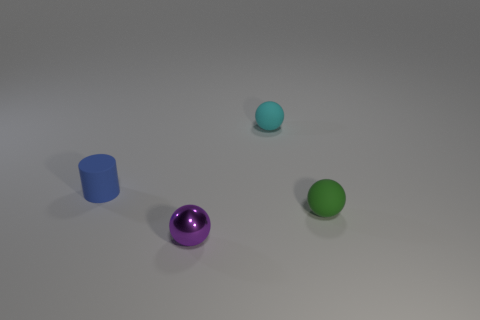Are there fewer purple objects behind the small cyan matte ball than small cyan rubber things?
Your answer should be compact. Yes. Are there any small purple things of the same shape as the blue object?
Make the answer very short. No. What shape is the green object that is the same size as the metal ball?
Offer a very short reply. Sphere. What number of things are tiny purple spheres or big gray matte things?
Ensure brevity in your answer.  1. Are there any big gray shiny things?
Provide a short and direct response. No. Are there fewer big brown objects than cylinders?
Offer a terse response. Yes. Are there any things of the same size as the blue cylinder?
Ensure brevity in your answer.  Yes. There is a tiny blue rubber object; is it the same shape as the thing that is behind the tiny rubber cylinder?
Your answer should be compact. No. What number of spheres are small green things or purple metal things?
Keep it short and to the point. 2. What color is the metallic sphere?
Your answer should be compact. Purple. 